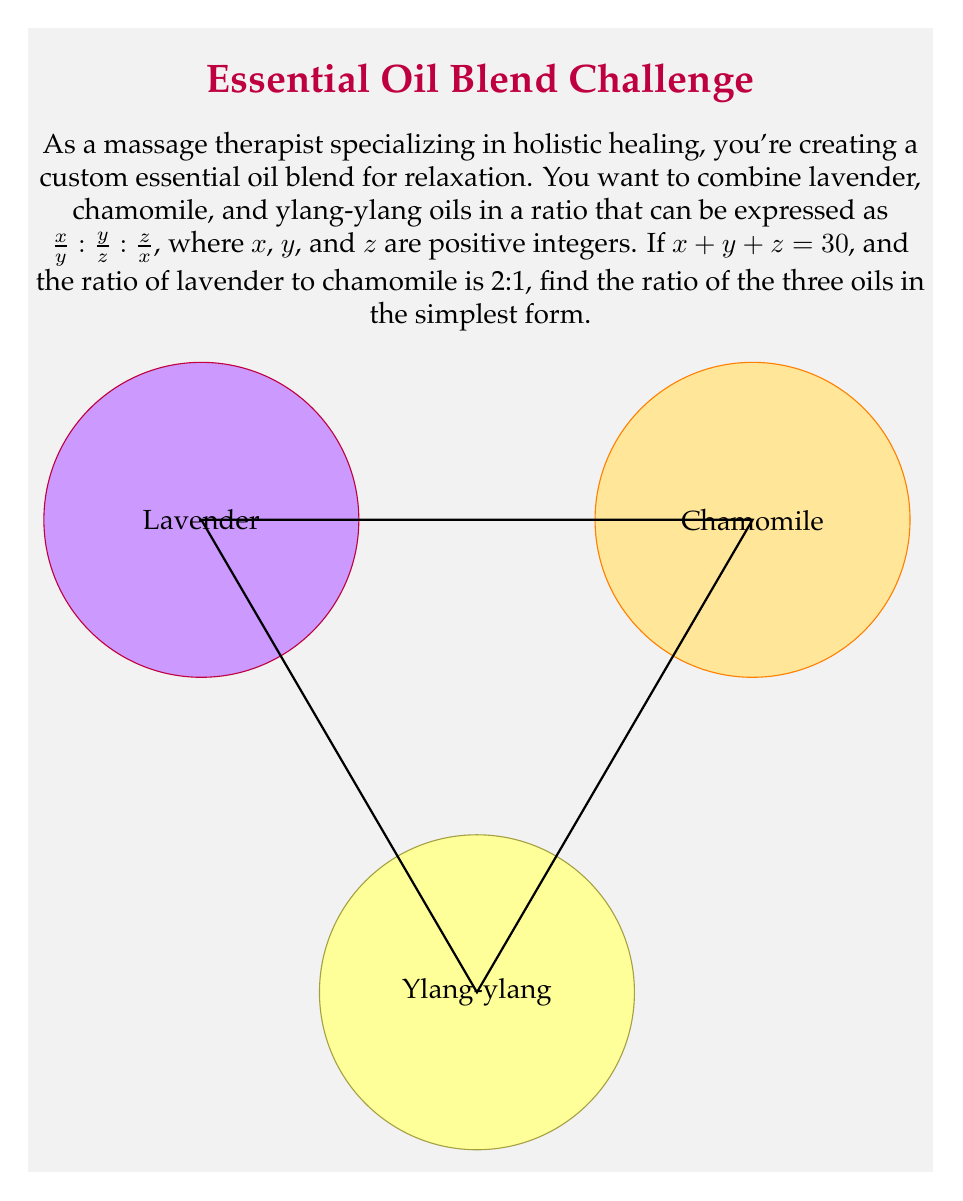Can you solve this math problem? Let's approach this step-by-step:

1) We're given that the ratio of lavender to chamomile is 2:1. This means:

   $\frac{x}{y} : \frac{y}{z} = 2 : 1$

2) This can be written as an equation:

   $\frac{x}{y} = 2 \cdot \frac{y}{z}$

3) Cross-multiplying:

   $xz = 2y^2$

4) We're also given that $x + y + z = 30$. Let's use this to find the values of $x$, $y$, and $z$.

5) Given the ratio $\frac{x}{y} : \frac{y}{z} : \frac{z}{x}$, let's assume $y = a$, where $a$ is some positive integer.

6) Then, from step 2, we can say $x = 2a$ and $z = \frac{a}{2}$.

7) Substituting these into the equation from step 4:

   $2a + a + \frac{a}{2} = 30$

8) Multiplying both sides by 2:

   $4a + 2a + a = 60$

9) Simplifying:

   $7a = 60$

10) Solving for $a$:

    $a = \frac{60}{7} = \frac{180}{21}$

11) Therefore:
    $x = 2a = \frac{360}{21}$
    $y = a = \frac{180}{21}$
    $z = \frac{a}{2} = \frac{90}{21}$

12) Simplifying these fractions:
    $x = \frac{360}{21} = \frac{120}{7}$
    $y = \frac{180}{21} = \frac{60}{7}$
    $z = \frac{90}{21} = \frac{30}{7}$

13) The ratio $\frac{x}{y} : \frac{y}{z} : \frac{z}{x}$ becomes:

    $\frac{120/7}{60/7} : \frac{60/7}{30/7} : \frac{30/7}{120/7} = 2 : 2 : \frac{1}{4}$

14) Multiplying all terms by 4 to eliminate fractions:

    $8 : 8 : 1$
Answer: $8 : 8 : 1$ 